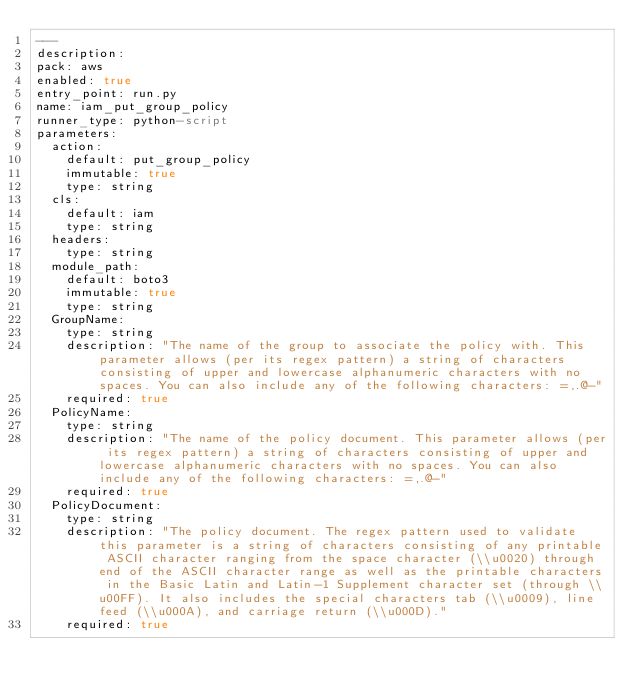<code> <loc_0><loc_0><loc_500><loc_500><_YAML_>---
description: 
pack: aws
enabled: true
entry_point: run.py
name: iam_put_group_policy
runner_type: python-script
parameters:
  action:
    default: put_group_policy
    immutable: true
    type: string
  cls:
    default: iam
    type: string
  headers:
    type: string
  module_path:
    default: boto3
    immutable: true
    type: string
  GroupName:
    type: string
    description: "The name of the group to associate the policy with. This parameter allows (per its regex pattern) a string of characters consisting of upper and lowercase alphanumeric characters with no spaces. You can also include any of the following characters: =,.@-"
    required: true
  PolicyName:
    type: string
    description: "The name of the policy document. This parameter allows (per its regex pattern) a string of characters consisting of upper and lowercase alphanumeric characters with no spaces. You can also include any of the following characters: =,.@-"
    required: true
  PolicyDocument:
    type: string
    description: "The policy document. The regex pattern used to validate this parameter is a string of characters consisting of any printable ASCII character ranging from the space character (\\u0020) through end of the ASCII character range as well as the printable characters in the Basic Latin and Latin-1 Supplement character set (through \\u00FF). It also includes the special characters tab (\\u0009), line feed (\\u000A), and carriage return (\\u000D)."
    required: true</code> 